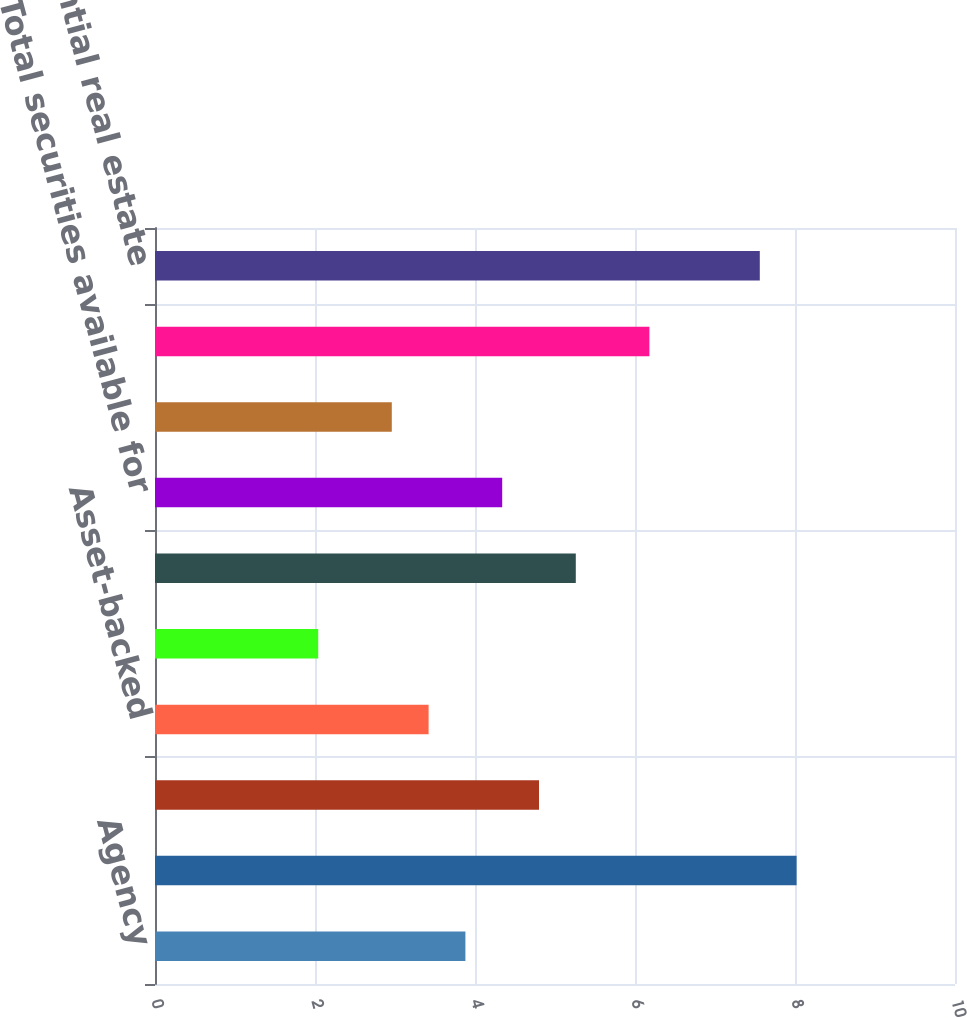<chart> <loc_0><loc_0><loc_500><loc_500><bar_chart><fcel>Agency<fcel>Non-agency<fcel>Commercial mortgage-backed<fcel>Asset-backed<fcel>US Treasury and government<fcel>Other<fcel>Total securities available for<fcel>Asset-backed US Treasury and<fcel>Total securities held to<fcel>Residential real estate<nl><fcel>3.88<fcel>8.02<fcel>4.8<fcel>3.42<fcel>2.04<fcel>5.26<fcel>4.34<fcel>2.96<fcel>6.18<fcel>7.56<nl></chart> 